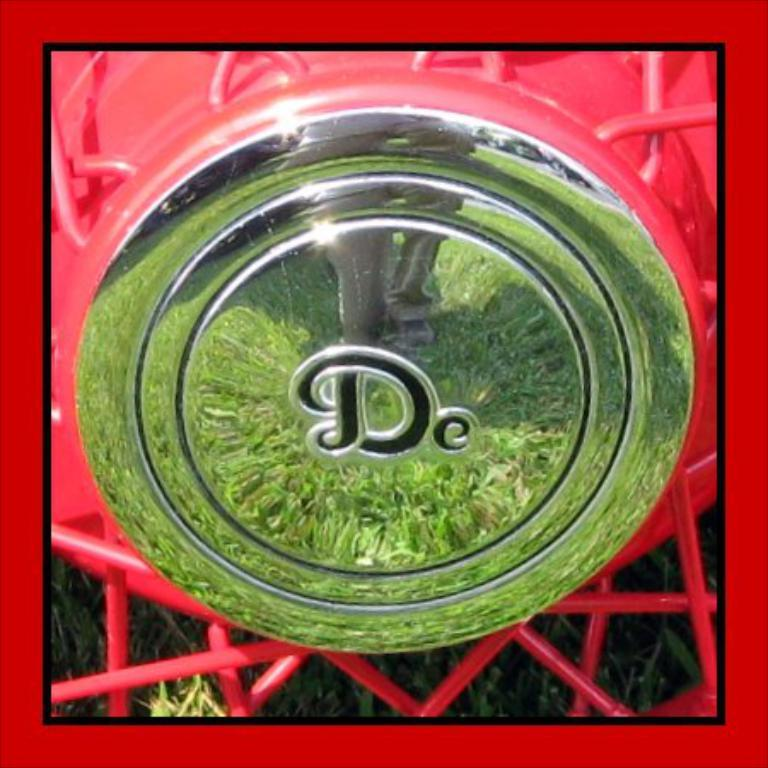What is the main feature of the image? There is a logo in the image. What can be seen in the reflection of the image? The reflection of people and grass is visible in the image. What is located behind the logo in the image? There is grass behind the logo in the image. Where is the judge standing in the image? There is no judge present in the image. Can you see any popcorn in the image? There is no popcorn present in the image. 